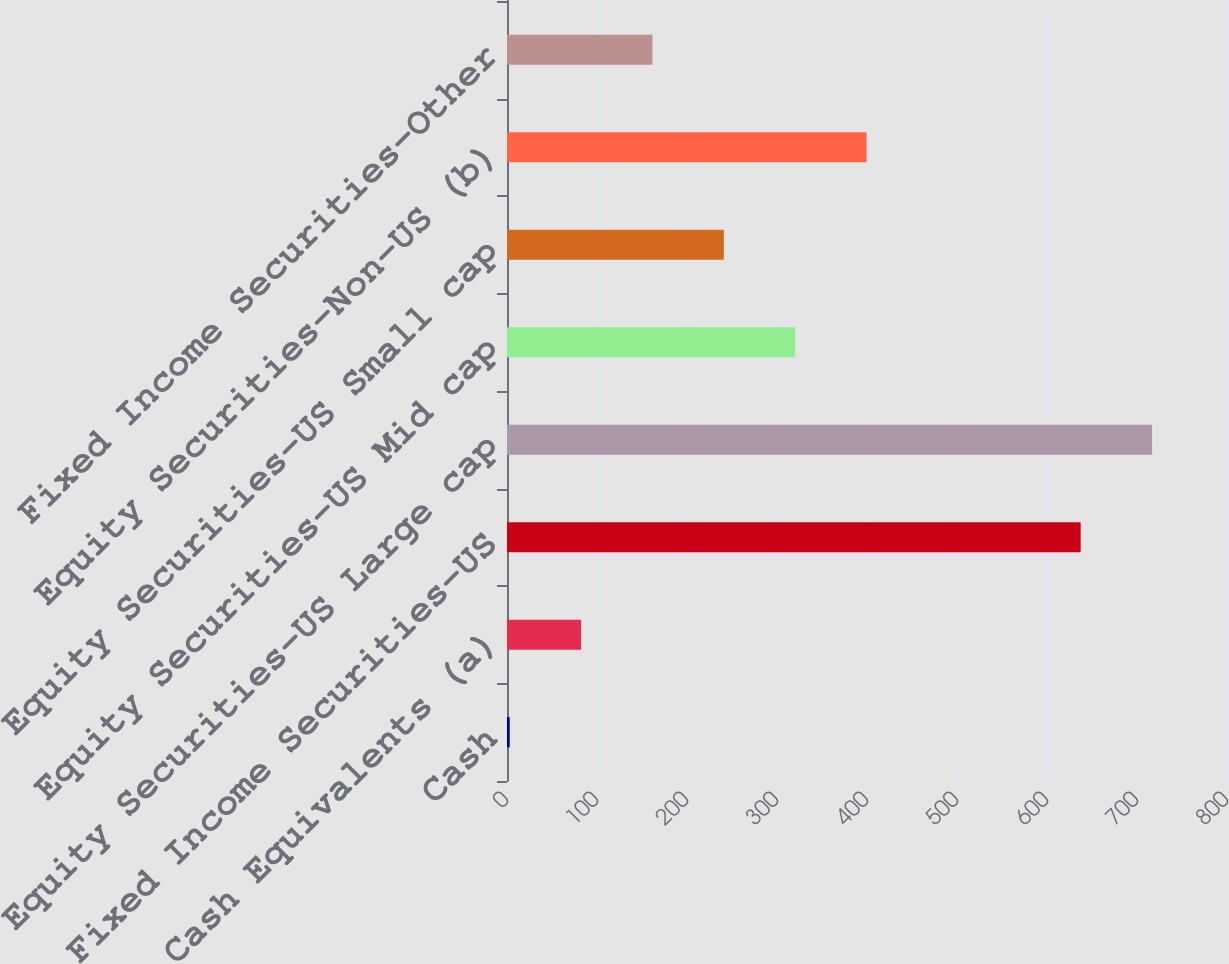Convert chart. <chart><loc_0><loc_0><loc_500><loc_500><bar_chart><fcel>Cash<fcel>Cash Equivalents (a)<fcel>Fixed Income Securities-US<fcel>Equity Securities-US Large cap<fcel>Equity Securities-US Mid cap<fcel>Equity Securities-US Small cap<fcel>Equity Securities-Non-US (b)<fcel>Fixed Income Securities-Other<nl><fcel>3<fcel>82.3<fcel>637.4<fcel>716.7<fcel>320.2<fcel>240.9<fcel>399.5<fcel>161.6<nl></chart> 